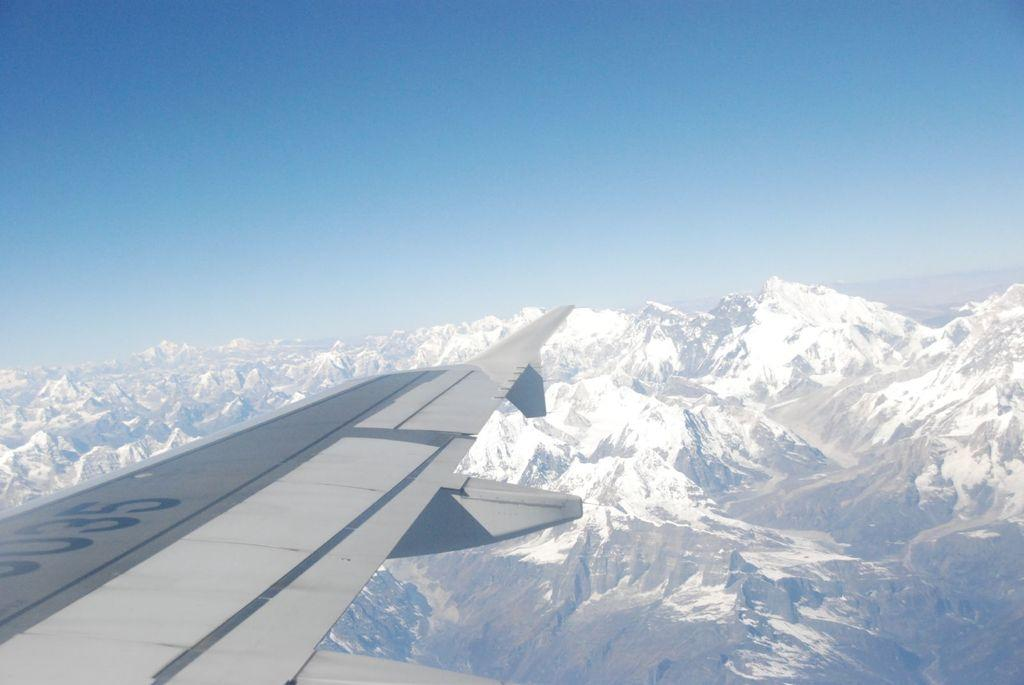<image>
Offer a succinct explanation of the picture presented. The wing of a plane has the numbers of 035. 